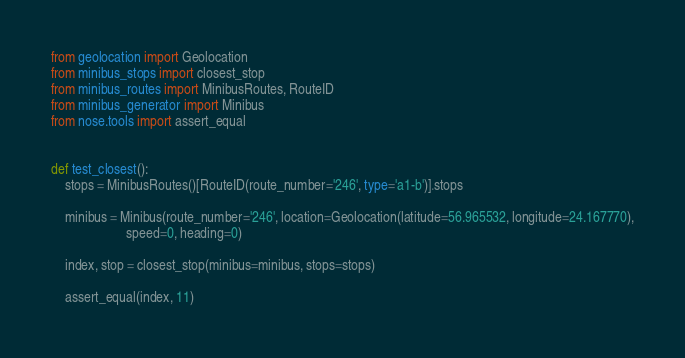<code> <loc_0><loc_0><loc_500><loc_500><_Python_>from geolocation import Geolocation
from minibus_stops import closest_stop
from minibus_routes import MinibusRoutes, RouteID
from minibus_generator import Minibus
from nose.tools import assert_equal


def test_closest():
    stops = MinibusRoutes()[RouteID(route_number='246', type='a1-b')].stops

    minibus = Minibus(route_number='246', location=Geolocation(latitude=56.965532, longitude=24.167770),
                      speed=0, heading=0)

    index, stop = closest_stop(minibus=minibus, stops=stops)

    assert_equal(index, 11)
</code> 